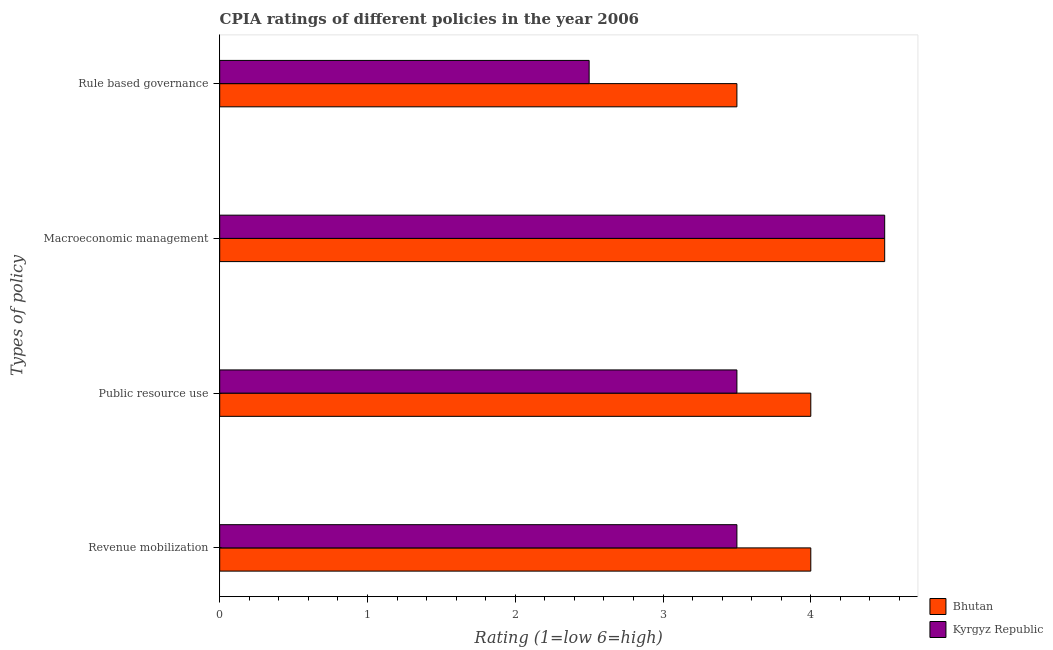How many different coloured bars are there?
Provide a short and direct response. 2. How many groups of bars are there?
Your answer should be very brief. 4. How many bars are there on the 2nd tick from the bottom?
Provide a succinct answer. 2. What is the label of the 3rd group of bars from the top?
Offer a terse response. Public resource use. What is the cpia rating of macroeconomic management in Bhutan?
Provide a succinct answer. 4.5. Across all countries, what is the maximum cpia rating of rule based governance?
Ensure brevity in your answer.  3.5. In which country was the cpia rating of revenue mobilization maximum?
Keep it short and to the point. Bhutan. In which country was the cpia rating of revenue mobilization minimum?
Ensure brevity in your answer.  Kyrgyz Republic. What is the average cpia rating of public resource use per country?
Ensure brevity in your answer.  3.75. In how many countries, is the cpia rating of rule based governance greater than 2.2 ?
Make the answer very short. 2. What is the ratio of the cpia rating of rule based governance in Kyrgyz Republic to that in Bhutan?
Offer a very short reply. 0.71. Is the difference between the cpia rating of revenue mobilization in Kyrgyz Republic and Bhutan greater than the difference between the cpia rating of macroeconomic management in Kyrgyz Republic and Bhutan?
Your response must be concise. No. What is the difference between the highest and the lowest cpia rating of macroeconomic management?
Give a very brief answer. 0. In how many countries, is the cpia rating of rule based governance greater than the average cpia rating of rule based governance taken over all countries?
Provide a short and direct response. 1. Is the sum of the cpia rating of revenue mobilization in Bhutan and Kyrgyz Republic greater than the maximum cpia rating of macroeconomic management across all countries?
Your response must be concise. Yes. What does the 1st bar from the top in Revenue mobilization represents?
Your response must be concise. Kyrgyz Republic. What does the 2nd bar from the bottom in Macroeconomic management represents?
Make the answer very short. Kyrgyz Republic. How many countries are there in the graph?
Provide a short and direct response. 2. What is the difference between two consecutive major ticks on the X-axis?
Give a very brief answer. 1. How many legend labels are there?
Keep it short and to the point. 2. What is the title of the graph?
Offer a terse response. CPIA ratings of different policies in the year 2006. Does "High income: OECD" appear as one of the legend labels in the graph?
Your answer should be compact. No. What is the label or title of the Y-axis?
Offer a terse response. Types of policy. What is the Rating (1=low 6=high) in Kyrgyz Republic in Revenue mobilization?
Offer a terse response. 3.5. What is the Rating (1=low 6=high) of Bhutan in Rule based governance?
Your response must be concise. 3.5. Across all Types of policy, what is the maximum Rating (1=low 6=high) in Bhutan?
Your response must be concise. 4.5. Across all Types of policy, what is the maximum Rating (1=low 6=high) in Kyrgyz Republic?
Make the answer very short. 4.5. Across all Types of policy, what is the minimum Rating (1=low 6=high) in Kyrgyz Republic?
Your answer should be very brief. 2.5. What is the total Rating (1=low 6=high) of Bhutan in the graph?
Offer a very short reply. 16. What is the total Rating (1=low 6=high) of Kyrgyz Republic in the graph?
Offer a very short reply. 14. What is the difference between the Rating (1=low 6=high) of Bhutan in Revenue mobilization and that in Macroeconomic management?
Your answer should be compact. -0.5. What is the difference between the Rating (1=low 6=high) in Kyrgyz Republic in Revenue mobilization and that in Macroeconomic management?
Your answer should be very brief. -1. What is the difference between the Rating (1=low 6=high) of Kyrgyz Republic in Public resource use and that in Macroeconomic management?
Your response must be concise. -1. What is the difference between the Rating (1=low 6=high) in Kyrgyz Republic in Macroeconomic management and that in Rule based governance?
Your answer should be very brief. 2. What is the difference between the Rating (1=low 6=high) in Bhutan in Revenue mobilization and the Rating (1=low 6=high) in Kyrgyz Republic in Public resource use?
Offer a very short reply. 0.5. What is the difference between the Rating (1=low 6=high) of Bhutan in Public resource use and the Rating (1=low 6=high) of Kyrgyz Republic in Rule based governance?
Your answer should be very brief. 1.5. What is the difference between the Rating (1=low 6=high) in Bhutan in Macroeconomic management and the Rating (1=low 6=high) in Kyrgyz Republic in Rule based governance?
Provide a succinct answer. 2. What is the average Rating (1=low 6=high) of Bhutan per Types of policy?
Give a very brief answer. 4. What is the average Rating (1=low 6=high) of Kyrgyz Republic per Types of policy?
Provide a short and direct response. 3.5. What is the difference between the Rating (1=low 6=high) of Bhutan and Rating (1=low 6=high) of Kyrgyz Republic in Revenue mobilization?
Provide a succinct answer. 0.5. What is the difference between the Rating (1=low 6=high) in Bhutan and Rating (1=low 6=high) in Kyrgyz Republic in Public resource use?
Ensure brevity in your answer.  0.5. What is the ratio of the Rating (1=low 6=high) of Bhutan in Revenue mobilization to that in Public resource use?
Provide a succinct answer. 1. What is the ratio of the Rating (1=low 6=high) of Kyrgyz Republic in Revenue mobilization to that in Public resource use?
Make the answer very short. 1. What is the ratio of the Rating (1=low 6=high) of Bhutan in Revenue mobilization to that in Macroeconomic management?
Your response must be concise. 0.89. What is the ratio of the Rating (1=low 6=high) of Bhutan in Revenue mobilization to that in Rule based governance?
Ensure brevity in your answer.  1.14. What is the ratio of the Rating (1=low 6=high) of Bhutan in Public resource use to that in Rule based governance?
Ensure brevity in your answer.  1.14. What is the ratio of the Rating (1=low 6=high) in Kyrgyz Republic in Public resource use to that in Rule based governance?
Provide a succinct answer. 1.4. What is the ratio of the Rating (1=low 6=high) in Kyrgyz Republic in Macroeconomic management to that in Rule based governance?
Your response must be concise. 1.8. What is the difference between the highest and the second highest Rating (1=low 6=high) in Bhutan?
Your answer should be compact. 0.5. What is the difference between the highest and the second highest Rating (1=low 6=high) of Kyrgyz Republic?
Ensure brevity in your answer.  1. What is the difference between the highest and the lowest Rating (1=low 6=high) in Bhutan?
Ensure brevity in your answer.  1. 